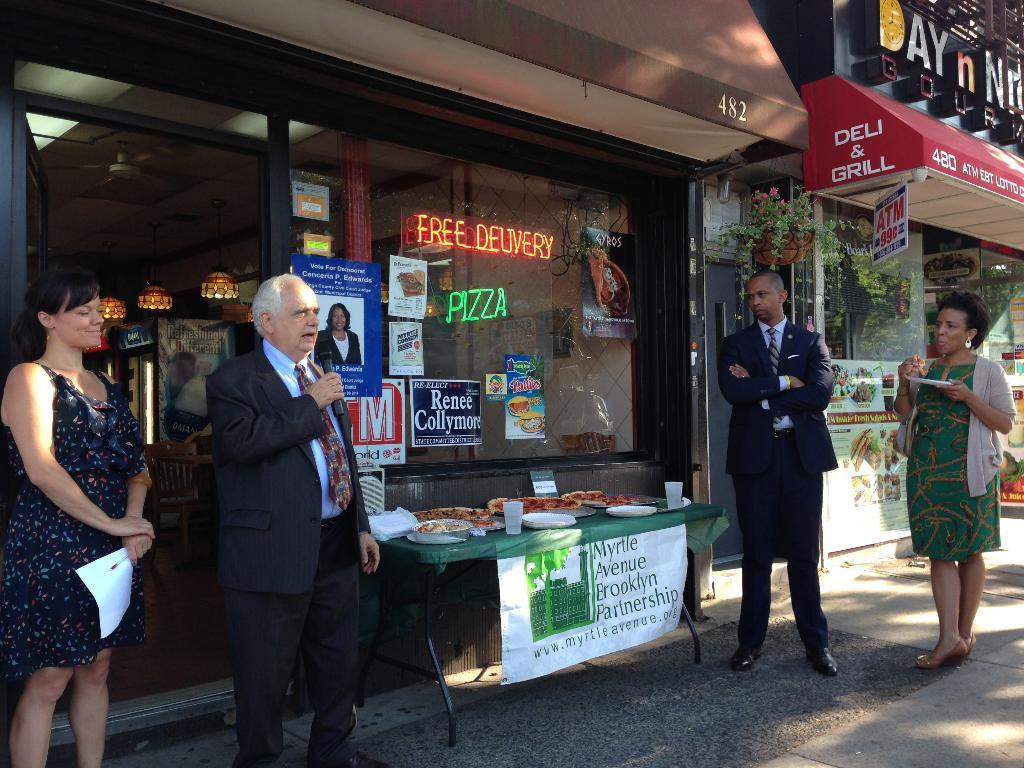How many people are in the image? There are four persons standing in the image. What is one of the persons doing with his hands? One of the persons is holding a mic in his hands. What is the person holding the mic doing? The person holding the mic is speaking. What can be seen in the background of the image? There are two stores in the background of the image. Is there any quicksand visible in the image? No, there is no quicksand present in the image. What type of seed is being planted by the person holding the mic? The person holding the mic is speaking, not planting seeds, and there is no seed visible in the image. 